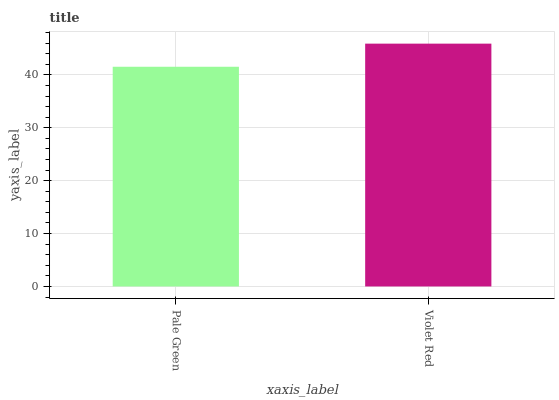Is Violet Red the minimum?
Answer yes or no. No. Is Violet Red greater than Pale Green?
Answer yes or no. Yes. Is Pale Green less than Violet Red?
Answer yes or no. Yes. Is Pale Green greater than Violet Red?
Answer yes or no. No. Is Violet Red less than Pale Green?
Answer yes or no. No. Is Violet Red the high median?
Answer yes or no. Yes. Is Pale Green the low median?
Answer yes or no. Yes. Is Pale Green the high median?
Answer yes or no. No. Is Violet Red the low median?
Answer yes or no. No. 